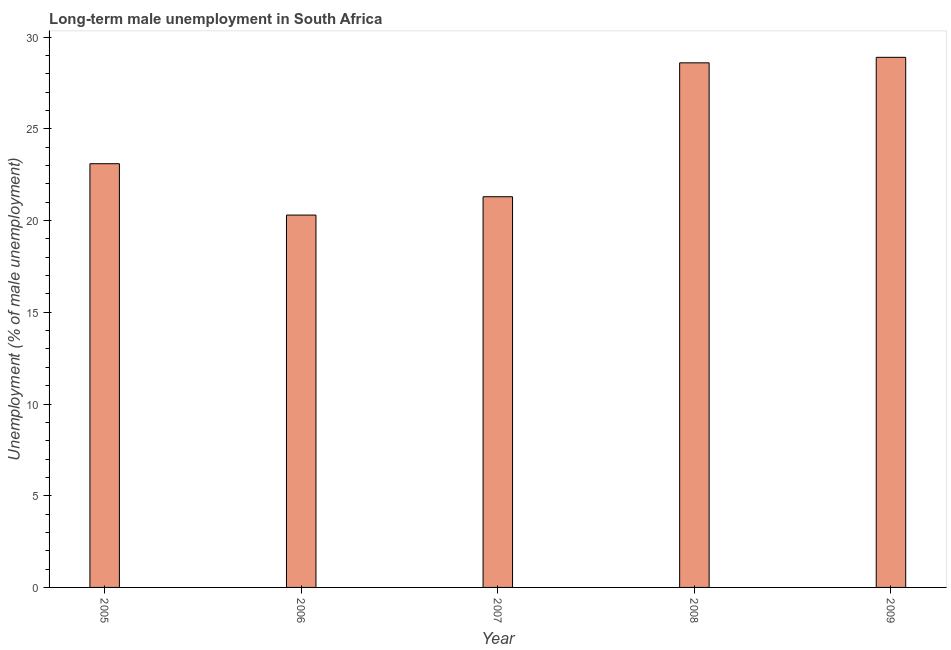What is the title of the graph?
Your response must be concise. Long-term male unemployment in South Africa. What is the label or title of the Y-axis?
Provide a short and direct response. Unemployment (% of male unemployment). What is the long-term male unemployment in 2005?
Keep it short and to the point. 23.1. Across all years, what is the maximum long-term male unemployment?
Your answer should be very brief. 28.9. Across all years, what is the minimum long-term male unemployment?
Ensure brevity in your answer.  20.3. In which year was the long-term male unemployment maximum?
Your response must be concise. 2009. What is the sum of the long-term male unemployment?
Offer a very short reply. 122.2. What is the average long-term male unemployment per year?
Your answer should be very brief. 24.44. What is the median long-term male unemployment?
Your response must be concise. 23.1. In how many years, is the long-term male unemployment greater than 13 %?
Keep it short and to the point. 5. Do a majority of the years between 2008 and 2005 (inclusive) have long-term male unemployment greater than 15 %?
Offer a very short reply. Yes. What is the ratio of the long-term male unemployment in 2005 to that in 2006?
Your answer should be compact. 1.14. Is the long-term male unemployment in 2005 less than that in 2007?
Provide a short and direct response. No. What is the difference between the highest and the second highest long-term male unemployment?
Provide a short and direct response. 0.3. What is the difference between the highest and the lowest long-term male unemployment?
Your answer should be very brief. 8.6. In how many years, is the long-term male unemployment greater than the average long-term male unemployment taken over all years?
Your response must be concise. 2. How many bars are there?
Make the answer very short. 5. Are all the bars in the graph horizontal?
Provide a succinct answer. No. What is the difference between two consecutive major ticks on the Y-axis?
Make the answer very short. 5. What is the Unemployment (% of male unemployment) of 2005?
Offer a very short reply. 23.1. What is the Unemployment (% of male unemployment) in 2006?
Make the answer very short. 20.3. What is the Unemployment (% of male unemployment) in 2007?
Ensure brevity in your answer.  21.3. What is the Unemployment (% of male unemployment) in 2008?
Your response must be concise. 28.6. What is the Unemployment (% of male unemployment) in 2009?
Your answer should be compact. 28.9. What is the difference between the Unemployment (% of male unemployment) in 2005 and 2006?
Give a very brief answer. 2.8. What is the difference between the Unemployment (% of male unemployment) in 2005 and 2007?
Your answer should be compact. 1.8. What is the difference between the Unemployment (% of male unemployment) in 2005 and 2008?
Your response must be concise. -5.5. What is the difference between the Unemployment (% of male unemployment) in 2006 and 2007?
Offer a very short reply. -1. What is the difference between the Unemployment (% of male unemployment) in 2006 and 2008?
Provide a succinct answer. -8.3. What is the difference between the Unemployment (% of male unemployment) in 2006 and 2009?
Your answer should be very brief. -8.6. What is the difference between the Unemployment (% of male unemployment) in 2007 and 2008?
Make the answer very short. -7.3. What is the difference between the Unemployment (% of male unemployment) in 2008 and 2009?
Keep it short and to the point. -0.3. What is the ratio of the Unemployment (% of male unemployment) in 2005 to that in 2006?
Provide a short and direct response. 1.14. What is the ratio of the Unemployment (% of male unemployment) in 2005 to that in 2007?
Offer a very short reply. 1.08. What is the ratio of the Unemployment (% of male unemployment) in 2005 to that in 2008?
Offer a terse response. 0.81. What is the ratio of the Unemployment (% of male unemployment) in 2005 to that in 2009?
Keep it short and to the point. 0.8. What is the ratio of the Unemployment (% of male unemployment) in 2006 to that in 2007?
Your answer should be compact. 0.95. What is the ratio of the Unemployment (% of male unemployment) in 2006 to that in 2008?
Keep it short and to the point. 0.71. What is the ratio of the Unemployment (% of male unemployment) in 2006 to that in 2009?
Provide a succinct answer. 0.7. What is the ratio of the Unemployment (% of male unemployment) in 2007 to that in 2008?
Your response must be concise. 0.74. What is the ratio of the Unemployment (% of male unemployment) in 2007 to that in 2009?
Provide a succinct answer. 0.74. 